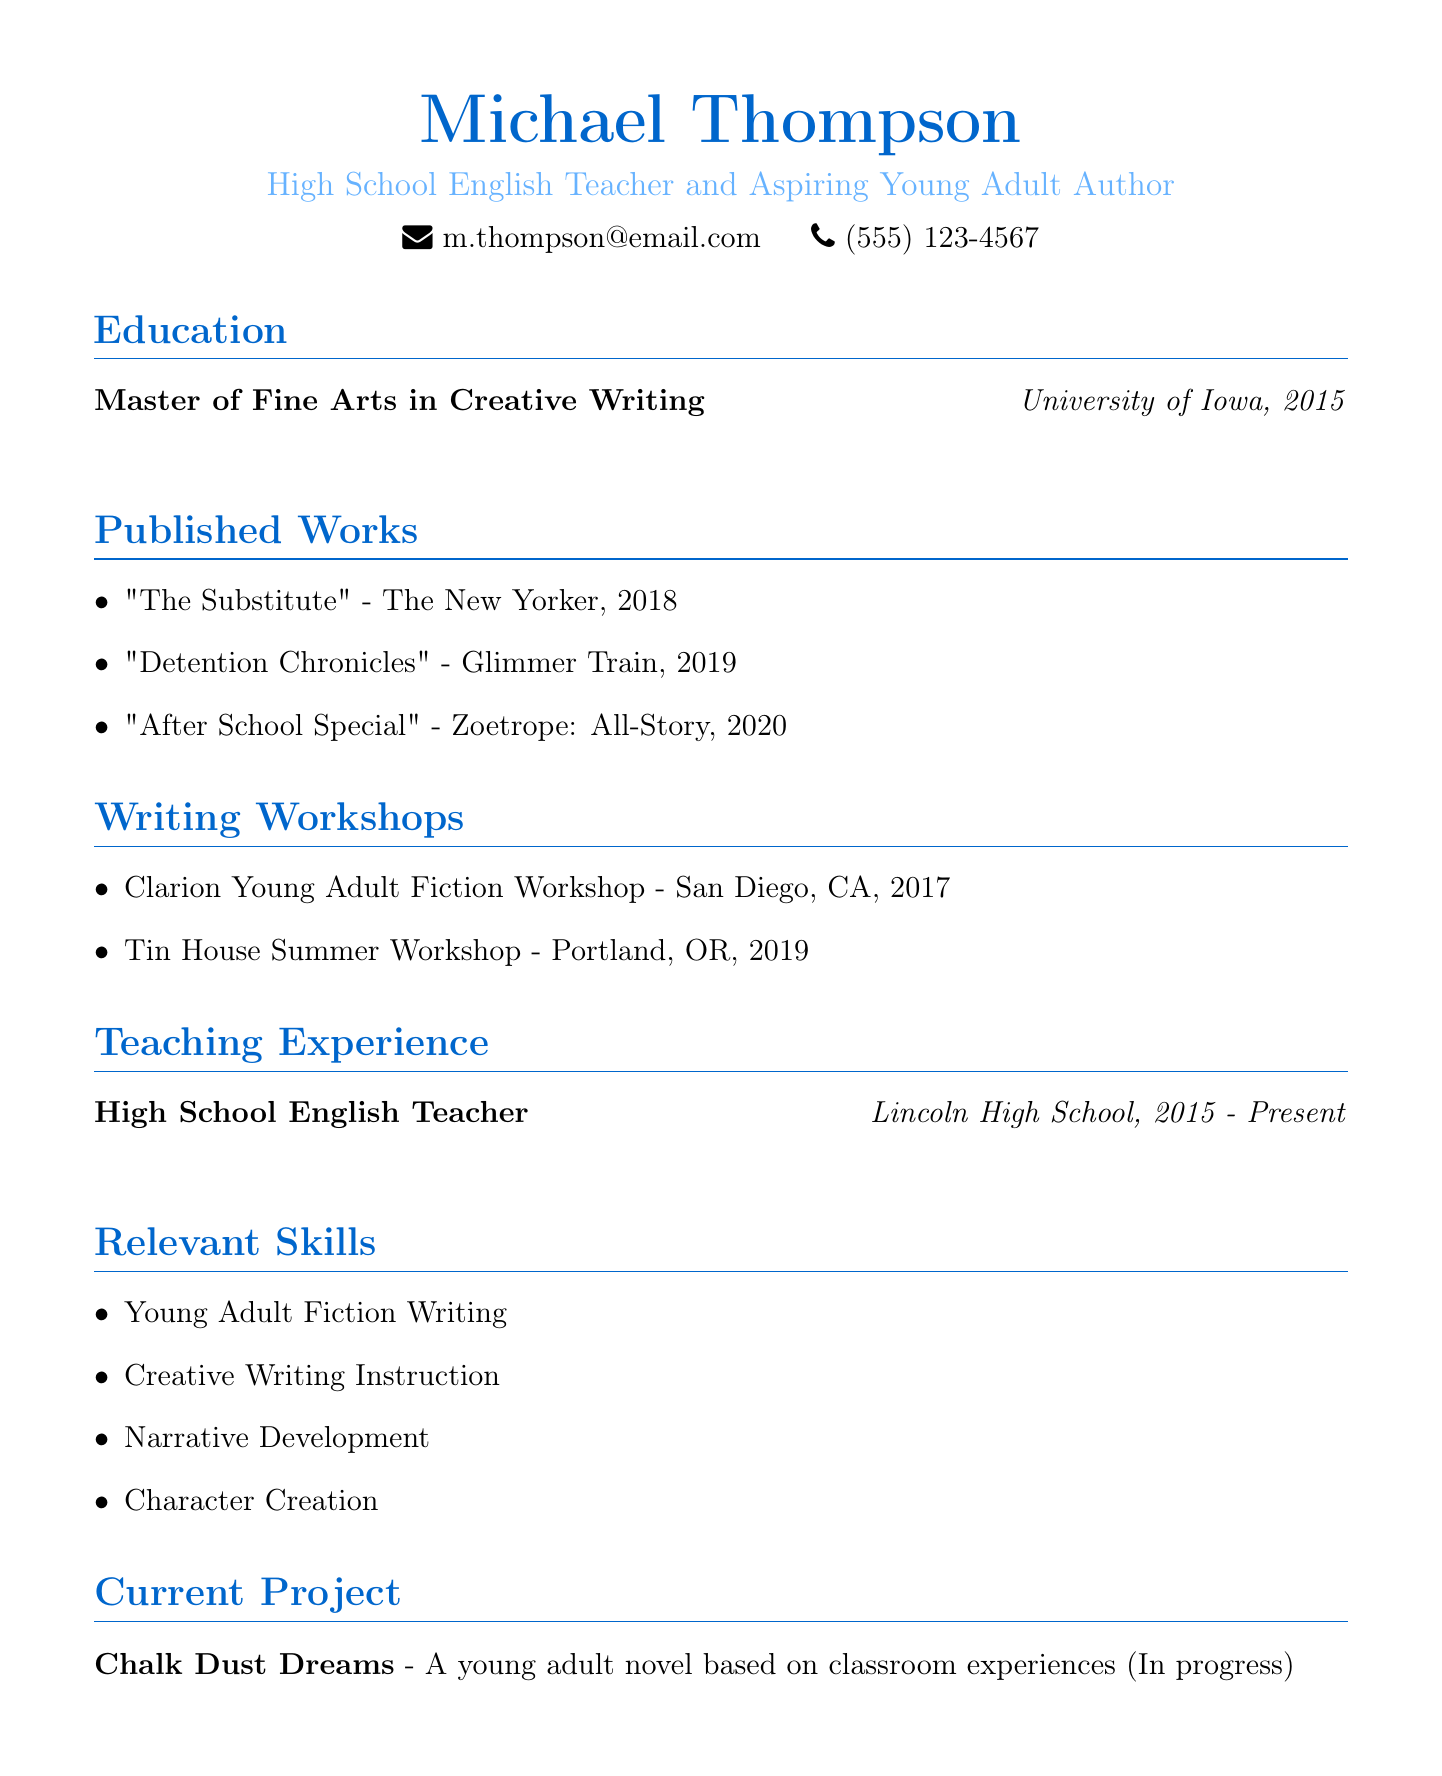What is the name of the author? The author's name is presented prominently at the top of the document.
Answer: Michael Thompson What degree does he hold? The document specifies the highest degree earned by the author.
Answer: Master of Fine Arts in Creative Writing In which publication did "The Substitute" appear? This question refers to the list of published works provided in the document.
Answer: The New Yorker What year was "Detention Chronicles" published? This question asks for the publication year of one of the author's works.
Answer: 2019 Where did Michael Thompson attend the Clarion Young Adult Fiction Workshop? This question requires knowledge of the workshop's location as stated in the document.
Answer: San Diego, CA How long has he been teaching at Lincoln High School? This question combines information from the teaching experience section regarding the duration of employment.
Answer: 2015 - Present Which skill related to writing is mentioned in the relevant skills section? The question seeks an example from the skills listed.
Answer: Young Adult Fiction Writing What is the title of his current project? This question directly refers to the project discussed at the end of the document.
Answer: Chalk Dust Dreams 